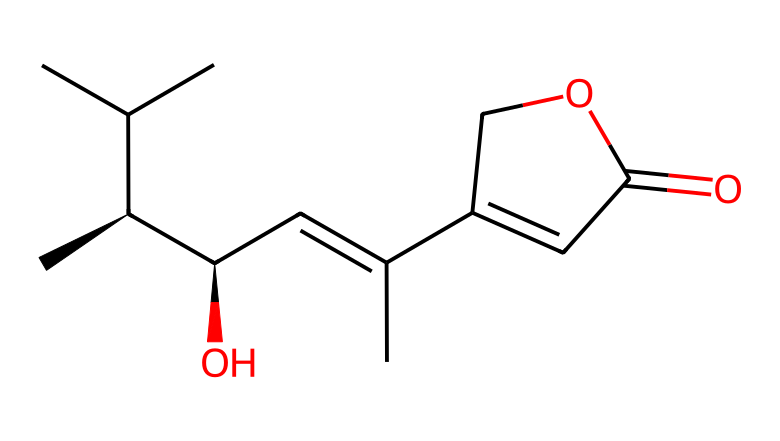how many carbon atoms are present in this chemical? By analyzing the SMILES representation, we count the 'C' characters that represent carbon atoms. In this case, there are 12 'C' characters in the SMILES.
Answer: 12 what is the functional group indicated by the "O" in the structure? The 'O' represents an oxygen atom, and its placement within a carbon chain typically indicates an alcohol or an ester group. In this SMILES, it is part of a carbon chain, indicating it is an alcohol group due to its linkage to a carbon and a hydrogen atom.
Answer: alcohol what is the name of this compound? The SMILES provided corresponds to compounds found in Ashwagandha, specifically withaferin A, which is the major bioactive component of Withania somnifera.
Answer: withaferin A does this chemical structure indicate any chiral centers? Yes, the notation "@H" in the SMILES indicates that there are chiral centers present in the structure. Chiral centers are typically denoted with an asterisk or '@' symbol. In the provided SMILES, there are multiple '@' symbols, indicating at least two chiral centers.
Answer: yes what type of chemical is this based on its structure? The presence of multiple rings, alkene structures, and functional groups suggests that this is a secondary metabolite, specifically a steroidal lactone, commonly found in adaptogenic herbs, such as Ashwagandha.
Answer: steroidal lactone how does this chemical contribute to adaptogenic properties? The structural aspects of this compound, such as the presence of specific functional groups and stereochemistry, allow it to modulate stress responses and influence hormone levels, which characterizes an adaptogen's effect. This functionality links to its ability to help the body adapt to stressors.
Answer: modulates stress responses 